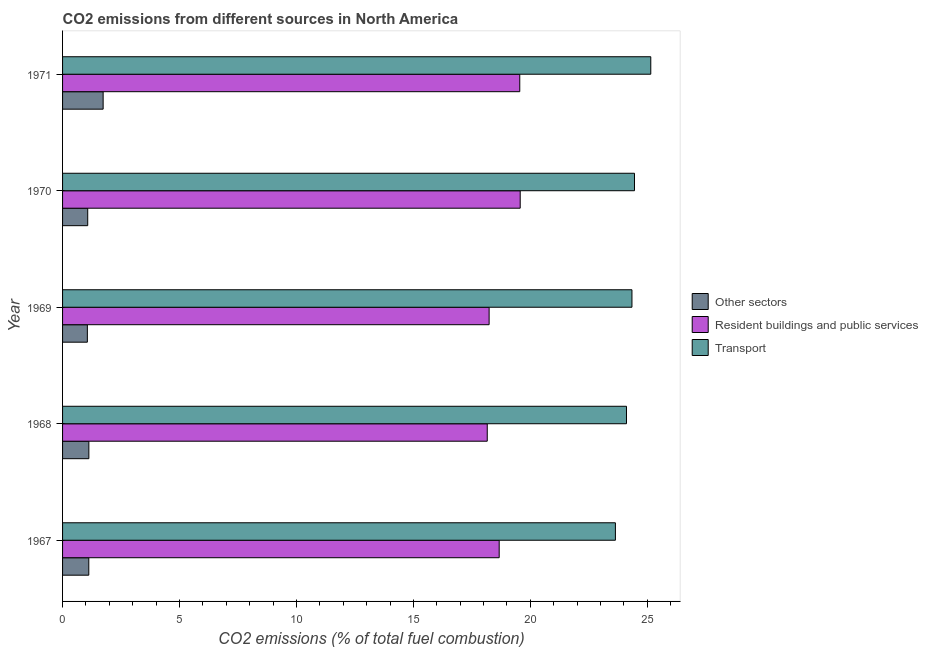How many different coloured bars are there?
Your answer should be compact. 3. How many groups of bars are there?
Offer a terse response. 5. How many bars are there on the 3rd tick from the top?
Ensure brevity in your answer.  3. How many bars are there on the 3rd tick from the bottom?
Your response must be concise. 3. What is the label of the 4th group of bars from the top?
Provide a succinct answer. 1968. What is the percentage of co2 emissions from transport in 1969?
Your answer should be compact. 24.34. Across all years, what is the maximum percentage of co2 emissions from other sectors?
Make the answer very short. 1.73. Across all years, what is the minimum percentage of co2 emissions from resident buildings and public services?
Your answer should be compact. 18.16. In which year was the percentage of co2 emissions from transport minimum?
Your response must be concise. 1967. What is the total percentage of co2 emissions from resident buildings and public services in the graph?
Provide a short and direct response. 94.17. What is the difference between the percentage of co2 emissions from other sectors in 1967 and that in 1970?
Provide a succinct answer. 0.05. What is the difference between the percentage of co2 emissions from other sectors in 1967 and the percentage of co2 emissions from transport in 1969?
Provide a succinct answer. -23.22. What is the average percentage of co2 emissions from transport per year?
Your answer should be very brief. 24.34. In the year 1967, what is the difference between the percentage of co2 emissions from resident buildings and public services and percentage of co2 emissions from transport?
Offer a terse response. -4.97. In how many years, is the percentage of co2 emissions from transport greater than 2 %?
Make the answer very short. 5. What is the ratio of the percentage of co2 emissions from transport in 1967 to that in 1970?
Your answer should be very brief. 0.97. What is the difference between the highest and the second highest percentage of co2 emissions from resident buildings and public services?
Your answer should be very brief. 0.02. What is the difference between the highest and the lowest percentage of co2 emissions from resident buildings and public services?
Your answer should be compact. 1.41. In how many years, is the percentage of co2 emissions from other sectors greater than the average percentage of co2 emissions from other sectors taken over all years?
Your answer should be compact. 1. Is the sum of the percentage of co2 emissions from transport in 1968 and 1971 greater than the maximum percentage of co2 emissions from other sectors across all years?
Provide a short and direct response. Yes. What does the 3rd bar from the top in 1970 represents?
Keep it short and to the point. Other sectors. What does the 3rd bar from the bottom in 1969 represents?
Your answer should be compact. Transport. Are all the bars in the graph horizontal?
Offer a terse response. Yes. How many years are there in the graph?
Make the answer very short. 5. What is the difference between two consecutive major ticks on the X-axis?
Provide a short and direct response. 5. Are the values on the major ticks of X-axis written in scientific E-notation?
Make the answer very short. No. Does the graph contain grids?
Offer a very short reply. No. Where does the legend appear in the graph?
Ensure brevity in your answer.  Center right. How are the legend labels stacked?
Offer a very short reply. Vertical. What is the title of the graph?
Your answer should be compact. CO2 emissions from different sources in North America. Does "Ages 15-20" appear as one of the legend labels in the graph?
Give a very brief answer. No. What is the label or title of the X-axis?
Offer a terse response. CO2 emissions (% of total fuel combustion). What is the CO2 emissions (% of total fuel combustion) of Other sectors in 1967?
Offer a very short reply. 1.12. What is the CO2 emissions (% of total fuel combustion) in Resident buildings and public services in 1967?
Offer a terse response. 18.67. What is the CO2 emissions (% of total fuel combustion) of Transport in 1967?
Your answer should be compact. 23.64. What is the CO2 emissions (% of total fuel combustion) of Other sectors in 1968?
Your answer should be compact. 1.12. What is the CO2 emissions (% of total fuel combustion) of Resident buildings and public services in 1968?
Your answer should be very brief. 18.16. What is the CO2 emissions (% of total fuel combustion) of Transport in 1968?
Your response must be concise. 24.11. What is the CO2 emissions (% of total fuel combustion) of Other sectors in 1969?
Keep it short and to the point. 1.06. What is the CO2 emissions (% of total fuel combustion) of Resident buildings and public services in 1969?
Make the answer very short. 18.24. What is the CO2 emissions (% of total fuel combustion) of Transport in 1969?
Provide a succinct answer. 24.34. What is the CO2 emissions (% of total fuel combustion) in Other sectors in 1970?
Keep it short and to the point. 1.08. What is the CO2 emissions (% of total fuel combustion) in Resident buildings and public services in 1970?
Make the answer very short. 19.57. What is the CO2 emissions (% of total fuel combustion) of Transport in 1970?
Your answer should be compact. 24.45. What is the CO2 emissions (% of total fuel combustion) of Other sectors in 1971?
Make the answer very short. 1.73. What is the CO2 emissions (% of total fuel combustion) in Resident buildings and public services in 1971?
Your response must be concise. 19.55. What is the CO2 emissions (% of total fuel combustion) of Transport in 1971?
Your answer should be compact. 25.15. Across all years, what is the maximum CO2 emissions (% of total fuel combustion) in Other sectors?
Provide a short and direct response. 1.73. Across all years, what is the maximum CO2 emissions (% of total fuel combustion) in Resident buildings and public services?
Make the answer very short. 19.57. Across all years, what is the maximum CO2 emissions (% of total fuel combustion) in Transport?
Give a very brief answer. 25.15. Across all years, what is the minimum CO2 emissions (% of total fuel combustion) of Other sectors?
Make the answer very short. 1.06. Across all years, what is the minimum CO2 emissions (% of total fuel combustion) of Resident buildings and public services?
Give a very brief answer. 18.16. Across all years, what is the minimum CO2 emissions (% of total fuel combustion) of Transport?
Offer a terse response. 23.64. What is the total CO2 emissions (% of total fuel combustion) of Other sectors in the graph?
Keep it short and to the point. 6.12. What is the total CO2 emissions (% of total fuel combustion) of Resident buildings and public services in the graph?
Your response must be concise. 94.17. What is the total CO2 emissions (% of total fuel combustion) of Transport in the graph?
Provide a short and direct response. 121.69. What is the difference between the CO2 emissions (% of total fuel combustion) of Other sectors in 1967 and that in 1968?
Offer a terse response. -0. What is the difference between the CO2 emissions (% of total fuel combustion) of Resident buildings and public services in 1967 and that in 1968?
Provide a succinct answer. 0.51. What is the difference between the CO2 emissions (% of total fuel combustion) in Transport in 1967 and that in 1968?
Provide a short and direct response. -0.47. What is the difference between the CO2 emissions (% of total fuel combustion) of Other sectors in 1967 and that in 1969?
Provide a short and direct response. 0.06. What is the difference between the CO2 emissions (% of total fuel combustion) of Resident buildings and public services in 1967 and that in 1969?
Offer a terse response. 0.43. What is the difference between the CO2 emissions (% of total fuel combustion) in Transport in 1967 and that in 1969?
Your answer should be very brief. -0.71. What is the difference between the CO2 emissions (% of total fuel combustion) in Other sectors in 1967 and that in 1970?
Give a very brief answer. 0.05. What is the difference between the CO2 emissions (% of total fuel combustion) in Resident buildings and public services in 1967 and that in 1970?
Offer a very short reply. -0.9. What is the difference between the CO2 emissions (% of total fuel combustion) in Transport in 1967 and that in 1970?
Offer a terse response. -0.82. What is the difference between the CO2 emissions (% of total fuel combustion) of Other sectors in 1967 and that in 1971?
Provide a succinct answer. -0.61. What is the difference between the CO2 emissions (% of total fuel combustion) in Resident buildings and public services in 1967 and that in 1971?
Give a very brief answer. -0.88. What is the difference between the CO2 emissions (% of total fuel combustion) of Transport in 1967 and that in 1971?
Make the answer very short. -1.51. What is the difference between the CO2 emissions (% of total fuel combustion) in Other sectors in 1968 and that in 1969?
Provide a short and direct response. 0.06. What is the difference between the CO2 emissions (% of total fuel combustion) in Resident buildings and public services in 1968 and that in 1969?
Offer a terse response. -0.08. What is the difference between the CO2 emissions (% of total fuel combustion) of Transport in 1968 and that in 1969?
Give a very brief answer. -0.23. What is the difference between the CO2 emissions (% of total fuel combustion) of Other sectors in 1968 and that in 1970?
Offer a terse response. 0.05. What is the difference between the CO2 emissions (% of total fuel combustion) in Resident buildings and public services in 1968 and that in 1970?
Ensure brevity in your answer.  -1.41. What is the difference between the CO2 emissions (% of total fuel combustion) of Transport in 1968 and that in 1970?
Keep it short and to the point. -0.34. What is the difference between the CO2 emissions (% of total fuel combustion) in Other sectors in 1968 and that in 1971?
Keep it short and to the point. -0.61. What is the difference between the CO2 emissions (% of total fuel combustion) of Resident buildings and public services in 1968 and that in 1971?
Offer a terse response. -1.39. What is the difference between the CO2 emissions (% of total fuel combustion) of Transport in 1968 and that in 1971?
Your answer should be compact. -1.04. What is the difference between the CO2 emissions (% of total fuel combustion) of Other sectors in 1969 and that in 1970?
Ensure brevity in your answer.  -0.02. What is the difference between the CO2 emissions (% of total fuel combustion) in Resident buildings and public services in 1969 and that in 1970?
Your answer should be compact. -1.33. What is the difference between the CO2 emissions (% of total fuel combustion) of Transport in 1969 and that in 1970?
Ensure brevity in your answer.  -0.11. What is the difference between the CO2 emissions (% of total fuel combustion) in Other sectors in 1969 and that in 1971?
Give a very brief answer. -0.67. What is the difference between the CO2 emissions (% of total fuel combustion) in Resident buildings and public services in 1969 and that in 1971?
Your response must be concise. -1.31. What is the difference between the CO2 emissions (% of total fuel combustion) in Transport in 1969 and that in 1971?
Provide a short and direct response. -0.81. What is the difference between the CO2 emissions (% of total fuel combustion) of Other sectors in 1970 and that in 1971?
Keep it short and to the point. -0.66. What is the difference between the CO2 emissions (% of total fuel combustion) in Resident buildings and public services in 1970 and that in 1971?
Offer a terse response. 0.02. What is the difference between the CO2 emissions (% of total fuel combustion) in Transport in 1970 and that in 1971?
Keep it short and to the point. -0.7. What is the difference between the CO2 emissions (% of total fuel combustion) in Other sectors in 1967 and the CO2 emissions (% of total fuel combustion) in Resident buildings and public services in 1968?
Give a very brief answer. -17.04. What is the difference between the CO2 emissions (% of total fuel combustion) in Other sectors in 1967 and the CO2 emissions (% of total fuel combustion) in Transport in 1968?
Keep it short and to the point. -22.99. What is the difference between the CO2 emissions (% of total fuel combustion) in Resident buildings and public services in 1967 and the CO2 emissions (% of total fuel combustion) in Transport in 1968?
Provide a succinct answer. -5.44. What is the difference between the CO2 emissions (% of total fuel combustion) of Other sectors in 1967 and the CO2 emissions (% of total fuel combustion) of Resident buildings and public services in 1969?
Ensure brevity in your answer.  -17.11. What is the difference between the CO2 emissions (% of total fuel combustion) of Other sectors in 1967 and the CO2 emissions (% of total fuel combustion) of Transport in 1969?
Your answer should be very brief. -23.22. What is the difference between the CO2 emissions (% of total fuel combustion) in Resident buildings and public services in 1967 and the CO2 emissions (% of total fuel combustion) in Transport in 1969?
Provide a short and direct response. -5.68. What is the difference between the CO2 emissions (% of total fuel combustion) in Other sectors in 1967 and the CO2 emissions (% of total fuel combustion) in Resident buildings and public services in 1970?
Keep it short and to the point. -18.44. What is the difference between the CO2 emissions (% of total fuel combustion) of Other sectors in 1967 and the CO2 emissions (% of total fuel combustion) of Transport in 1970?
Make the answer very short. -23.33. What is the difference between the CO2 emissions (% of total fuel combustion) in Resident buildings and public services in 1967 and the CO2 emissions (% of total fuel combustion) in Transport in 1970?
Ensure brevity in your answer.  -5.78. What is the difference between the CO2 emissions (% of total fuel combustion) of Other sectors in 1967 and the CO2 emissions (% of total fuel combustion) of Resident buildings and public services in 1971?
Ensure brevity in your answer.  -18.43. What is the difference between the CO2 emissions (% of total fuel combustion) in Other sectors in 1967 and the CO2 emissions (% of total fuel combustion) in Transport in 1971?
Ensure brevity in your answer.  -24.03. What is the difference between the CO2 emissions (% of total fuel combustion) of Resident buildings and public services in 1967 and the CO2 emissions (% of total fuel combustion) of Transport in 1971?
Keep it short and to the point. -6.48. What is the difference between the CO2 emissions (% of total fuel combustion) of Other sectors in 1968 and the CO2 emissions (% of total fuel combustion) of Resident buildings and public services in 1969?
Your answer should be compact. -17.11. What is the difference between the CO2 emissions (% of total fuel combustion) of Other sectors in 1968 and the CO2 emissions (% of total fuel combustion) of Transport in 1969?
Provide a succinct answer. -23.22. What is the difference between the CO2 emissions (% of total fuel combustion) of Resident buildings and public services in 1968 and the CO2 emissions (% of total fuel combustion) of Transport in 1969?
Offer a terse response. -6.19. What is the difference between the CO2 emissions (% of total fuel combustion) of Other sectors in 1968 and the CO2 emissions (% of total fuel combustion) of Resident buildings and public services in 1970?
Your response must be concise. -18.44. What is the difference between the CO2 emissions (% of total fuel combustion) of Other sectors in 1968 and the CO2 emissions (% of total fuel combustion) of Transport in 1970?
Your answer should be compact. -23.33. What is the difference between the CO2 emissions (% of total fuel combustion) in Resident buildings and public services in 1968 and the CO2 emissions (% of total fuel combustion) in Transport in 1970?
Ensure brevity in your answer.  -6.29. What is the difference between the CO2 emissions (% of total fuel combustion) in Other sectors in 1968 and the CO2 emissions (% of total fuel combustion) in Resident buildings and public services in 1971?
Make the answer very short. -18.42. What is the difference between the CO2 emissions (% of total fuel combustion) in Other sectors in 1968 and the CO2 emissions (% of total fuel combustion) in Transport in 1971?
Your answer should be compact. -24.02. What is the difference between the CO2 emissions (% of total fuel combustion) in Resident buildings and public services in 1968 and the CO2 emissions (% of total fuel combustion) in Transport in 1971?
Provide a short and direct response. -6.99. What is the difference between the CO2 emissions (% of total fuel combustion) of Other sectors in 1969 and the CO2 emissions (% of total fuel combustion) of Resident buildings and public services in 1970?
Offer a very short reply. -18.51. What is the difference between the CO2 emissions (% of total fuel combustion) in Other sectors in 1969 and the CO2 emissions (% of total fuel combustion) in Transport in 1970?
Offer a very short reply. -23.39. What is the difference between the CO2 emissions (% of total fuel combustion) in Resident buildings and public services in 1969 and the CO2 emissions (% of total fuel combustion) in Transport in 1970?
Provide a short and direct response. -6.21. What is the difference between the CO2 emissions (% of total fuel combustion) of Other sectors in 1969 and the CO2 emissions (% of total fuel combustion) of Resident buildings and public services in 1971?
Your answer should be very brief. -18.49. What is the difference between the CO2 emissions (% of total fuel combustion) of Other sectors in 1969 and the CO2 emissions (% of total fuel combustion) of Transport in 1971?
Provide a short and direct response. -24.09. What is the difference between the CO2 emissions (% of total fuel combustion) in Resident buildings and public services in 1969 and the CO2 emissions (% of total fuel combustion) in Transport in 1971?
Offer a terse response. -6.91. What is the difference between the CO2 emissions (% of total fuel combustion) in Other sectors in 1970 and the CO2 emissions (% of total fuel combustion) in Resident buildings and public services in 1971?
Your answer should be compact. -18.47. What is the difference between the CO2 emissions (% of total fuel combustion) in Other sectors in 1970 and the CO2 emissions (% of total fuel combustion) in Transport in 1971?
Offer a very short reply. -24.07. What is the difference between the CO2 emissions (% of total fuel combustion) in Resident buildings and public services in 1970 and the CO2 emissions (% of total fuel combustion) in Transport in 1971?
Your answer should be very brief. -5.58. What is the average CO2 emissions (% of total fuel combustion) in Other sectors per year?
Make the answer very short. 1.22. What is the average CO2 emissions (% of total fuel combustion) in Resident buildings and public services per year?
Your response must be concise. 18.83. What is the average CO2 emissions (% of total fuel combustion) of Transport per year?
Provide a short and direct response. 24.34. In the year 1967, what is the difference between the CO2 emissions (% of total fuel combustion) of Other sectors and CO2 emissions (% of total fuel combustion) of Resident buildings and public services?
Make the answer very short. -17.55. In the year 1967, what is the difference between the CO2 emissions (% of total fuel combustion) of Other sectors and CO2 emissions (% of total fuel combustion) of Transport?
Keep it short and to the point. -22.51. In the year 1967, what is the difference between the CO2 emissions (% of total fuel combustion) in Resident buildings and public services and CO2 emissions (% of total fuel combustion) in Transport?
Provide a succinct answer. -4.97. In the year 1968, what is the difference between the CO2 emissions (% of total fuel combustion) in Other sectors and CO2 emissions (% of total fuel combustion) in Resident buildings and public services?
Offer a terse response. -17.03. In the year 1968, what is the difference between the CO2 emissions (% of total fuel combustion) of Other sectors and CO2 emissions (% of total fuel combustion) of Transport?
Give a very brief answer. -22.98. In the year 1968, what is the difference between the CO2 emissions (% of total fuel combustion) in Resident buildings and public services and CO2 emissions (% of total fuel combustion) in Transport?
Your response must be concise. -5.95. In the year 1969, what is the difference between the CO2 emissions (% of total fuel combustion) in Other sectors and CO2 emissions (% of total fuel combustion) in Resident buildings and public services?
Your answer should be compact. -17.18. In the year 1969, what is the difference between the CO2 emissions (% of total fuel combustion) in Other sectors and CO2 emissions (% of total fuel combustion) in Transport?
Offer a terse response. -23.28. In the year 1969, what is the difference between the CO2 emissions (% of total fuel combustion) of Resident buildings and public services and CO2 emissions (% of total fuel combustion) of Transport?
Provide a succinct answer. -6.11. In the year 1970, what is the difference between the CO2 emissions (% of total fuel combustion) in Other sectors and CO2 emissions (% of total fuel combustion) in Resident buildings and public services?
Your response must be concise. -18.49. In the year 1970, what is the difference between the CO2 emissions (% of total fuel combustion) in Other sectors and CO2 emissions (% of total fuel combustion) in Transport?
Your response must be concise. -23.38. In the year 1970, what is the difference between the CO2 emissions (% of total fuel combustion) in Resident buildings and public services and CO2 emissions (% of total fuel combustion) in Transport?
Your answer should be very brief. -4.89. In the year 1971, what is the difference between the CO2 emissions (% of total fuel combustion) in Other sectors and CO2 emissions (% of total fuel combustion) in Resident buildings and public services?
Your answer should be compact. -17.81. In the year 1971, what is the difference between the CO2 emissions (% of total fuel combustion) of Other sectors and CO2 emissions (% of total fuel combustion) of Transport?
Offer a very short reply. -23.41. In the year 1971, what is the difference between the CO2 emissions (% of total fuel combustion) in Resident buildings and public services and CO2 emissions (% of total fuel combustion) in Transport?
Provide a succinct answer. -5.6. What is the ratio of the CO2 emissions (% of total fuel combustion) in Other sectors in 1967 to that in 1968?
Ensure brevity in your answer.  1. What is the ratio of the CO2 emissions (% of total fuel combustion) of Resident buildings and public services in 1967 to that in 1968?
Make the answer very short. 1.03. What is the ratio of the CO2 emissions (% of total fuel combustion) of Transport in 1967 to that in 1968?
Keep it short and to the point. 0.98. What is the ratio of the CO2 emissions (% of total fuel combustion) in Other sectors in 1967 to that in 1969?
Your answer should be very brief. 1.06. What is the ratio of the CO2 emissions (% of total fuel combustion) of Resident buildings and public services in 1967 to that in 1969?
Make the answer very short. 1.02. What is the ratio of the CO2 emissions (% of total fuel combustion) in Transport in 1967 to that in 1969?
Your answer should be compact. 0.97. What is the ratio of the CO2 emissions (% of total fuel combustion) in Other sectors in 1967 to that in 1970?
Make the answer very short. 1.04. What is the ratio of the CO2 emissions (% of total fuel combustion) in Resident buildings and public services in 1967 to that in 1970?
Make the answer very short. 0.95. What is the ratio of the CO2 emissions (% of total fuel combustion) in Transport in 1967 to that in 1970?
Make the answer very short. 0.97. What is the ratio of the CO2 emissions (% of total fuel combustion) in Other sectors in 1967 to that in 1971?
Provide a succinct answer. 0.65. What is the ratio of the CO2 emissions (% of total fuel combustion) in Resident buildings and public services in 1967 to that in 1971?
Offer a very short reply. 0.95. What is the ratio of the CO2 emissions (% of total fuel combustion) in Transport in 1967 to that in 1971?
Provide a short and direct response. 0.94. What is the ratio of the CO2 emissions (% of total fuel combustion) of Other sectors in 1968 to that in 1969?
Provide a short and direct response. 1.06. What is the ratio of the CO2 emissions (% of total fuel combustion) of Transport in 1968 to that in 1969?
Your answer should be very brief. 0.99. What is the ratio of the CO2 emissions (% of total fuel combustion) in Other sectors in 1968 to that in 1970?
Ensure brevity in your answer.  1.05. What is the ratio of the CO2 emissions (% of total fuel combustion) in Resident buildings and public services in 1968 to that in 1970?
Provide a succinct answer. 0.93. What is the ratio of the CO2 emissions (% of total fuel combustion) in Transport in 1968 to that in 1970?
Your answer should be compact. 0.99. What is the ratio of the CO2 emissions (% of total fuel combustion) in Other sectors in 1968 to that in 1971?
Make the answer very short. 0.65. What is the ratio of the CO2 emissions (% of total fuel combustion) of Resident buildings and public services in 1968 to that in 1971?
Provide a succinct answer. 0.93. What is the ratio of the CO2 emissions (% of total fuel combustion) in Transport in 1968 to that in 1971?
Provide a succinct answer. 0.96. What is the ratio of the CO2 emissions (% of total fuel combustion) of Other sectors in 1969 to that in 1970?
Your response must be concise. 0.99. What is the ratio of the CO2 emissions (% of total fuel combustion) of Resident buildings and public services in 1969 to that in 1970?
Give a very brief answer. 0.93. What is the ratio of the CO2 emissions (% of total fuel combustion) of Other sectors in 1969 to that in 1971?
Offer a very short reply. 0.61. What is the ratio of the CO2 emissions (% of total fuel combustion) of Resident buildings and public services in 1969 to that in 1971?
Provide a succinct answer. 0.93. What is the ratio of the CO2 emissions (% of total fuel combustion) in Other sectors in 1970 to that in 1971?
Give a very brief answer. 0.62. What is the ratio of the CO2 emissions (% of total fuel combustion) of Transport in 1970 to that in 1971?
Keep it short and to the point. 0.97. What is the difference between the highest and the second highest CO2 emissions (% of total fuel combustion) of Other sectors?
Your answer should be compact. 0.61. What is the difference between the highest and the second highest CO2 emissions (% of total fuel combustion) of Resident buildings and public services?
Make the answer very short. 0.02. What is the difference between the highest and the second highest CO2 emissions (% of total fuel combustion) in Transport?
Provide a succinct answer. 0.7. What is the difference between the highest and the lowest CO2 emissions (% of total fuel combustion) of Other sectors?
Provide a succinct answer. 0.67. What is the difference between the highest and the lowest CO2 emissions (% of total fuel combustion) in Resident buildings and public services?
Your response must be concise. 1.41. What is the difference between the highest and the lowest CO2 emissions (% of total fuel combustion) in Transport?
Your answer should be very brief. 1.51. 